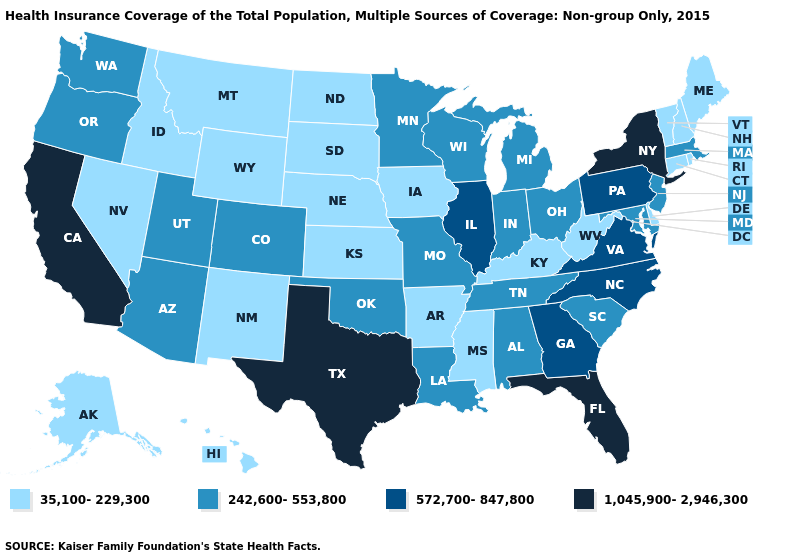What is the lowest value in the Northeast?
Be succinct. 35,100-229,300. What is the lowest value in states that border Kentucky?
Write a very short answer. 35,100-229,300. Does Arizona have a lower value than Florida?
Quick response, please. Yes. Name the states that have a value in the range 1,045,900-2,946,300?
Short answer required. California, Florida, New York, Texas. Among the states that border Pennsylvania , which have the highest value?
Keep it brief. New York. Does Michigan have the same value as Georgia?
Concise answer only. No. Does New York have the lowest value in the Northeast?
Concise answer only. No. Does California have the highest value in the USA?
Keep it brief. Yes. Does the first symbol in the legend represent the smallest category?
Concise answer only. Yes. Name the states that have a value in the range 572,700-847,800?
Short answer required. Georgia, Illinois, North Carolina, Pennsylvania, Virginia. Name the states that have a value in the range 35,100-229,300?
Give a very brief answer. Alaska, Arkansas, Connecticut, Delaware, Hawaii, Idaho, Iowa, Kansas, Kentucky, Maine, Mississippi, Montana, Nebraska, Nevada, New Hampshire, New Mexico, North Dakota, Rhode Island, South Dakota, Vermont, West Virginia, Wyoming. Among the states that border Virginia , which have the highest value?
Be succinct. North Carolina. What is the lowest value in the USA?
Concise answer only. 35,100-229,300. Does New Jersey have the same value as Alabama?
Short answer required. Yes. 